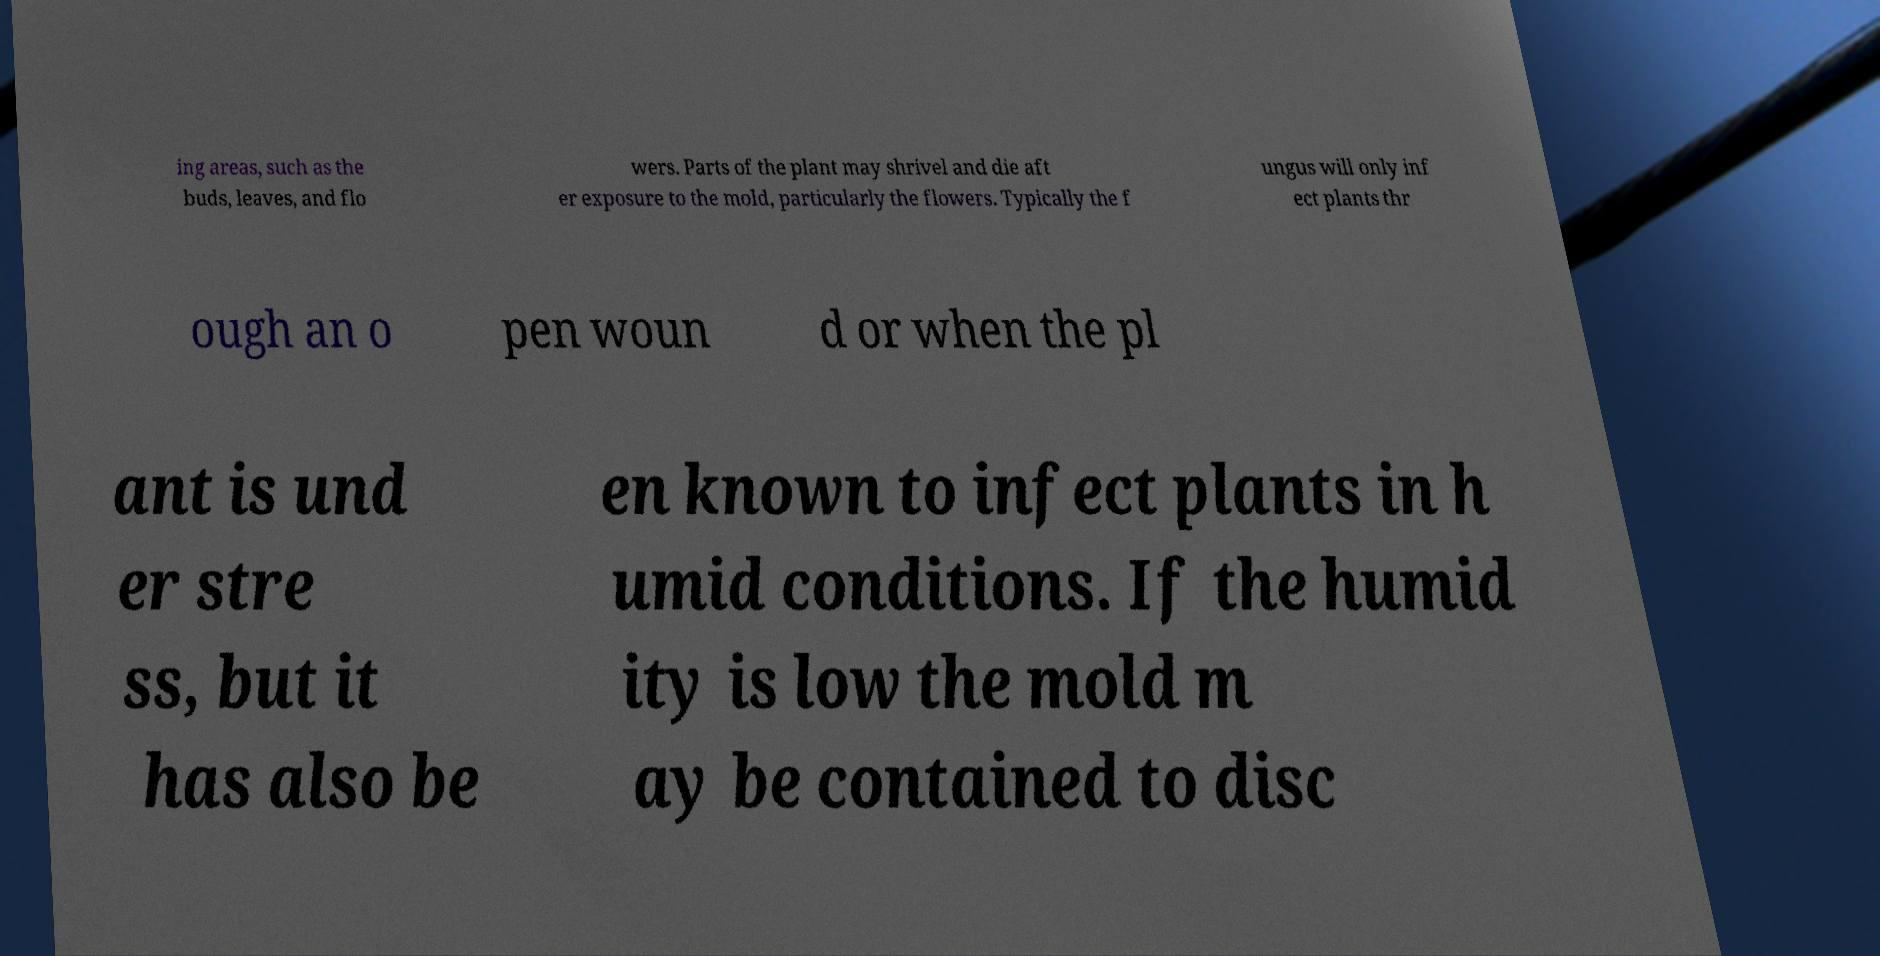I need the written content from this picture converted into text. Can you do that? ing areas, such as the buds, leaves, and flo wers. Parts of the plant may shrivel and die aft er exposure to the mold, particularly the flowers. Typically the f ungus will only inf ect plants thr ough an o pen woun d or when the pl ant is und er stre ss, but it has also be en known to infect plants in h umid conditions. If the humid ity is low the mold m ay be contained to disc 